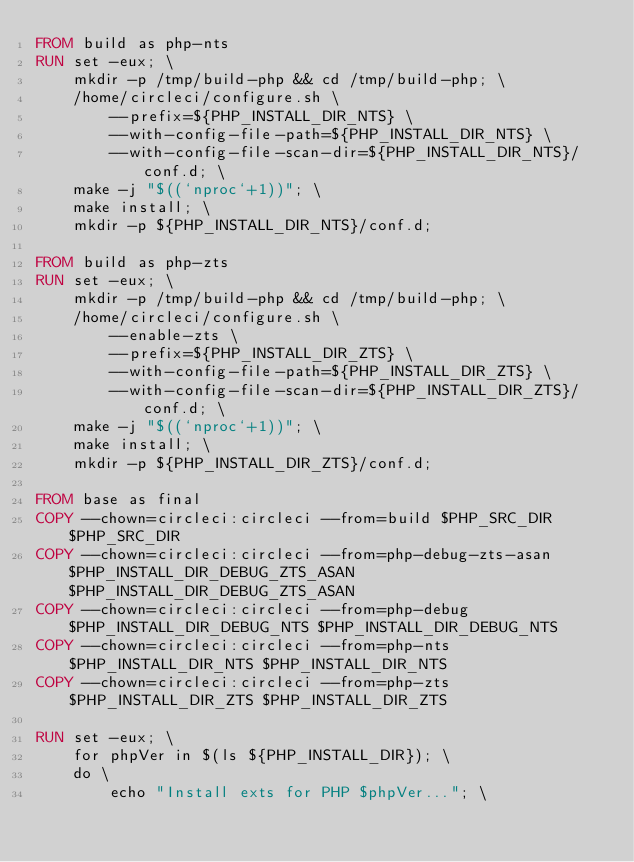Convert code to text. <code><loc_0><loc_0><loc_500><loc_500><_Dockerfile_>FROM build as php-nts
RUN set -eux; \
    mkdir -p /tmp/build-php && cd /tmp/build-php; \
    /home/circleci/configure.sh \
        --prefix=${PHP_INSTALL_DIR_NTS} \
        --with-config-file-path=${PHP_INSTALL_DIR_NTS} \
        --with-config-file-scan-dir=${PHP_INSTALL_DIR_NTS}/conf.d; \
    make -j "$((`nproc`+1))"; \
    make install; \
    mkdir -p ${PHP_INSTALL_DIR_NTS}/conf.d;

FROM build as php-zts
RUN set -eux; \
    mkdir -p /tmp/build-php && cd /tmp/build-php; \
    /home/circleci/configure.sh \
        --enable-zts \
        --prefix=${PHP_INSTALL_DIR_ZTS} \
        --with-config-file-path=${PHP_INSTALL_DIR_ZTS} \
        --with-config-file-scan-dir=${PHP_INSTALL_DIR_ZTS}/conf.d; \
    make -j "$((`nproc`+1))"; \
    make install; \
    mkdir -p ${PHP_INSTALL_DIR_ZTS}/conf.d;

FROM base as final
COPY --chown=circleci:circleci --from=build $PHP_SRC_DIR $PHP_SRC_DIR
COPY --chown=circleci:circleci --from=php-debug-zts-asan $PHP_INSTALL_DIR_DEBUG_ZTS_ASAN $PHP_INSTALL_DIR_DEBUG_ZTS_ASAN
COPY --chown=circleci:circleci --from=php-debug $PHP_INSTALL_DIR_DEBUG_NTS $PHP_INSTALL_DIR_DEBUG_NTS
COPY --chown=circleci:circleci --from=php-nts $PHP_INSTALL_DIR_NTS $PHP_INSTALL_DIR_NTS
COPY --chown=circleci:circleci --from=php-zts $PHP_INSTALL_DIR_ZTS $PHP_INSTALL_DIR_ZTS

RUN set -eux; \
    for phpVer in $(ls ${PHP_INSTALL_DIR}); \
    do \
        echo "Install exts for PHP $phpVer..."; \</code> 